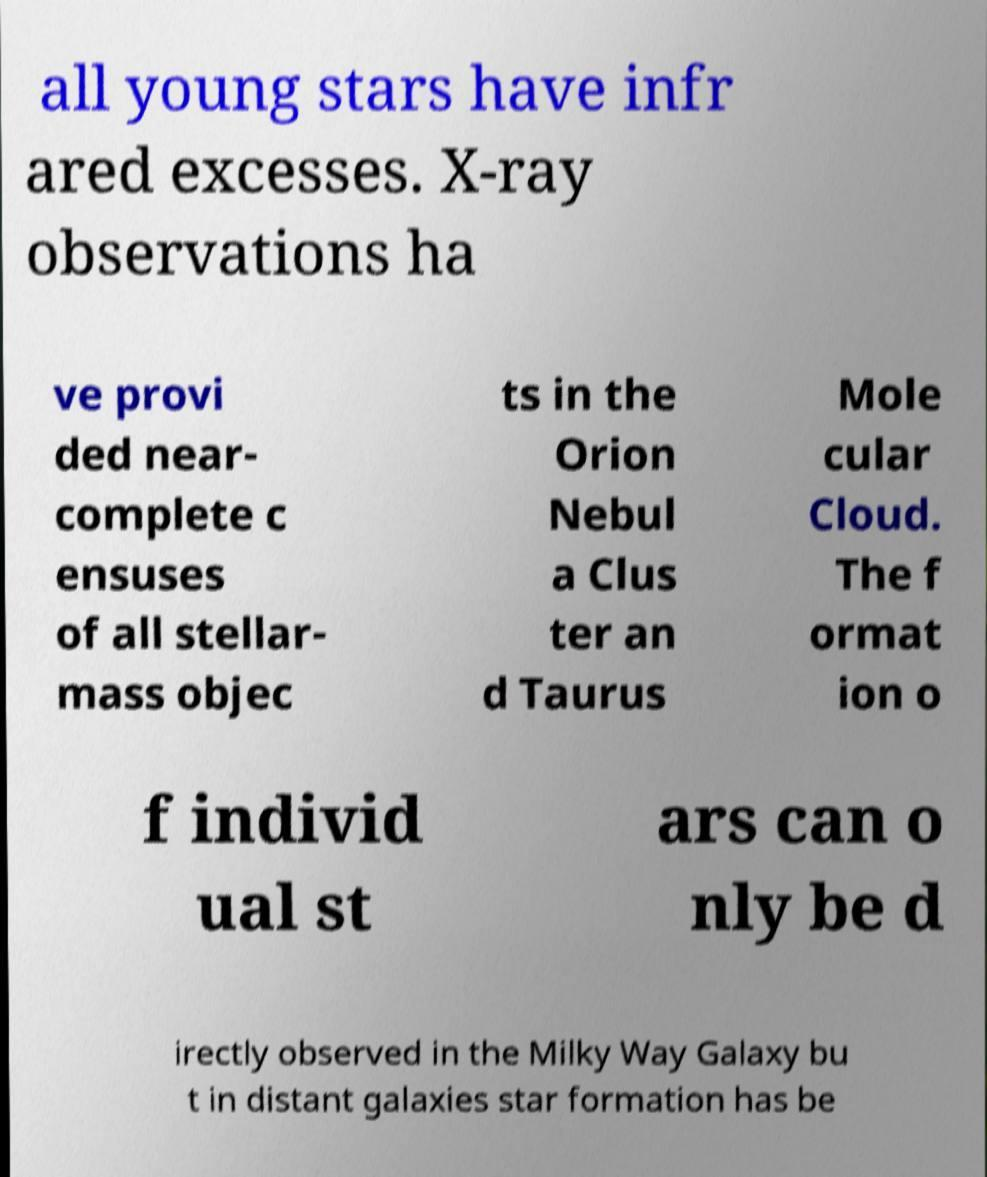I need the written content from this picture converted into text. Can you do that? all young stars have infr ared excesses. X-ray observations ha ve provi ded near- complete c ensuses of all stellar- mass objec ts in the Orion Nebul a Clus ter an d Taurus Mole cular Cloud. The f ormat ion o f individ ual st ars can o nly be d irectly observed in the Milky Way Galaxy bu t in distant galaxies star formation has be 